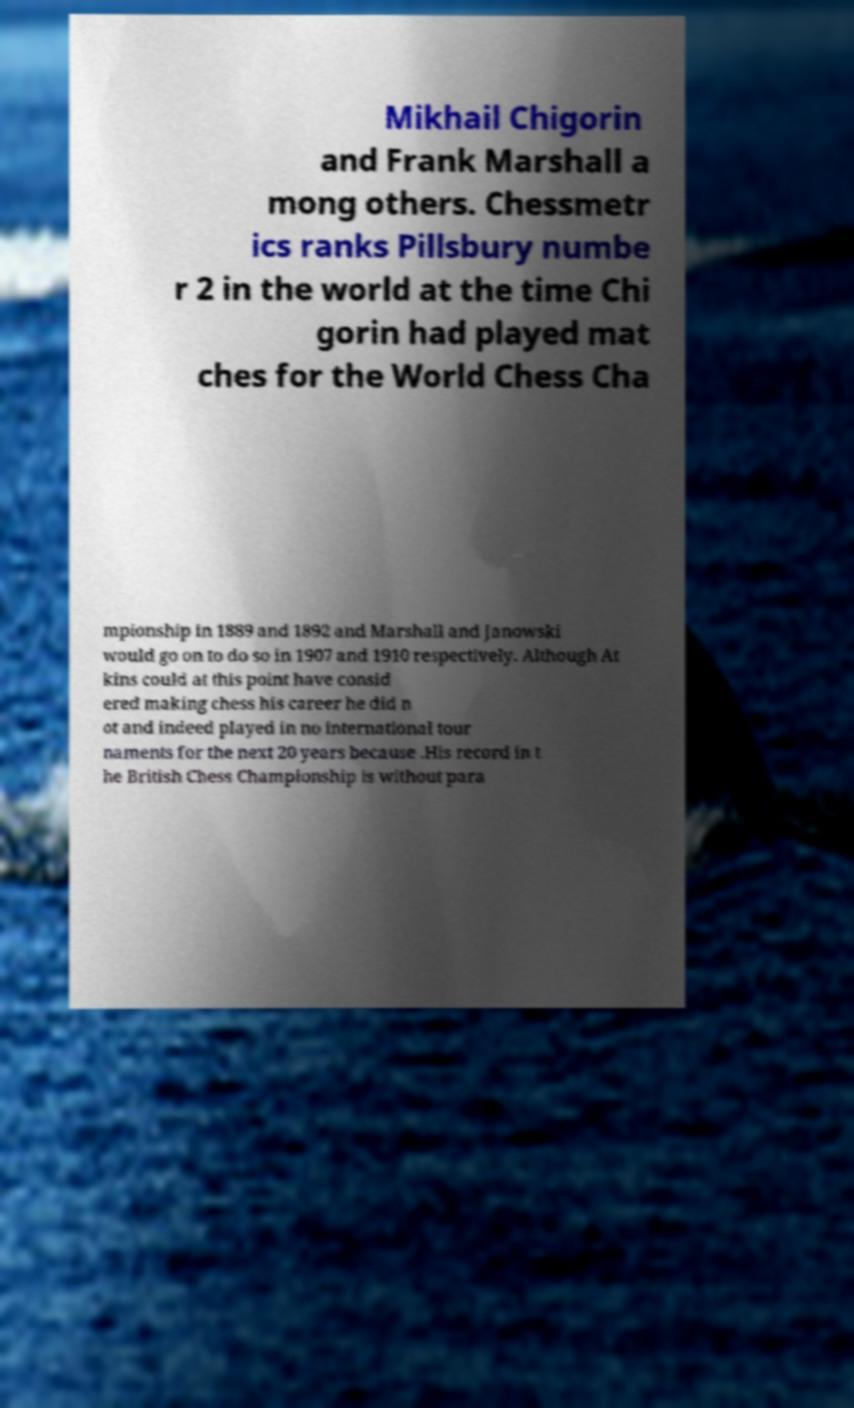There's text embedded in this image that I need extracted. Can you transcribe it verbatim? Mikhail Chigorin and Frank Marshall a mong others. Chessmetr ics ranks Pillsbury numbe r 2 in the world at the time Chi gorin had played mat ches for the World Chess Cha mpionship in 1889 and 1892 and Marshall and Janowski would go on to do so in 1907 and 1910 respectively. Although At kins could at this point have consid ered making chess his career he did n ot and indeed played in no international tour naments for the next 20 years because .His record in t he British Chess Championship is without para 